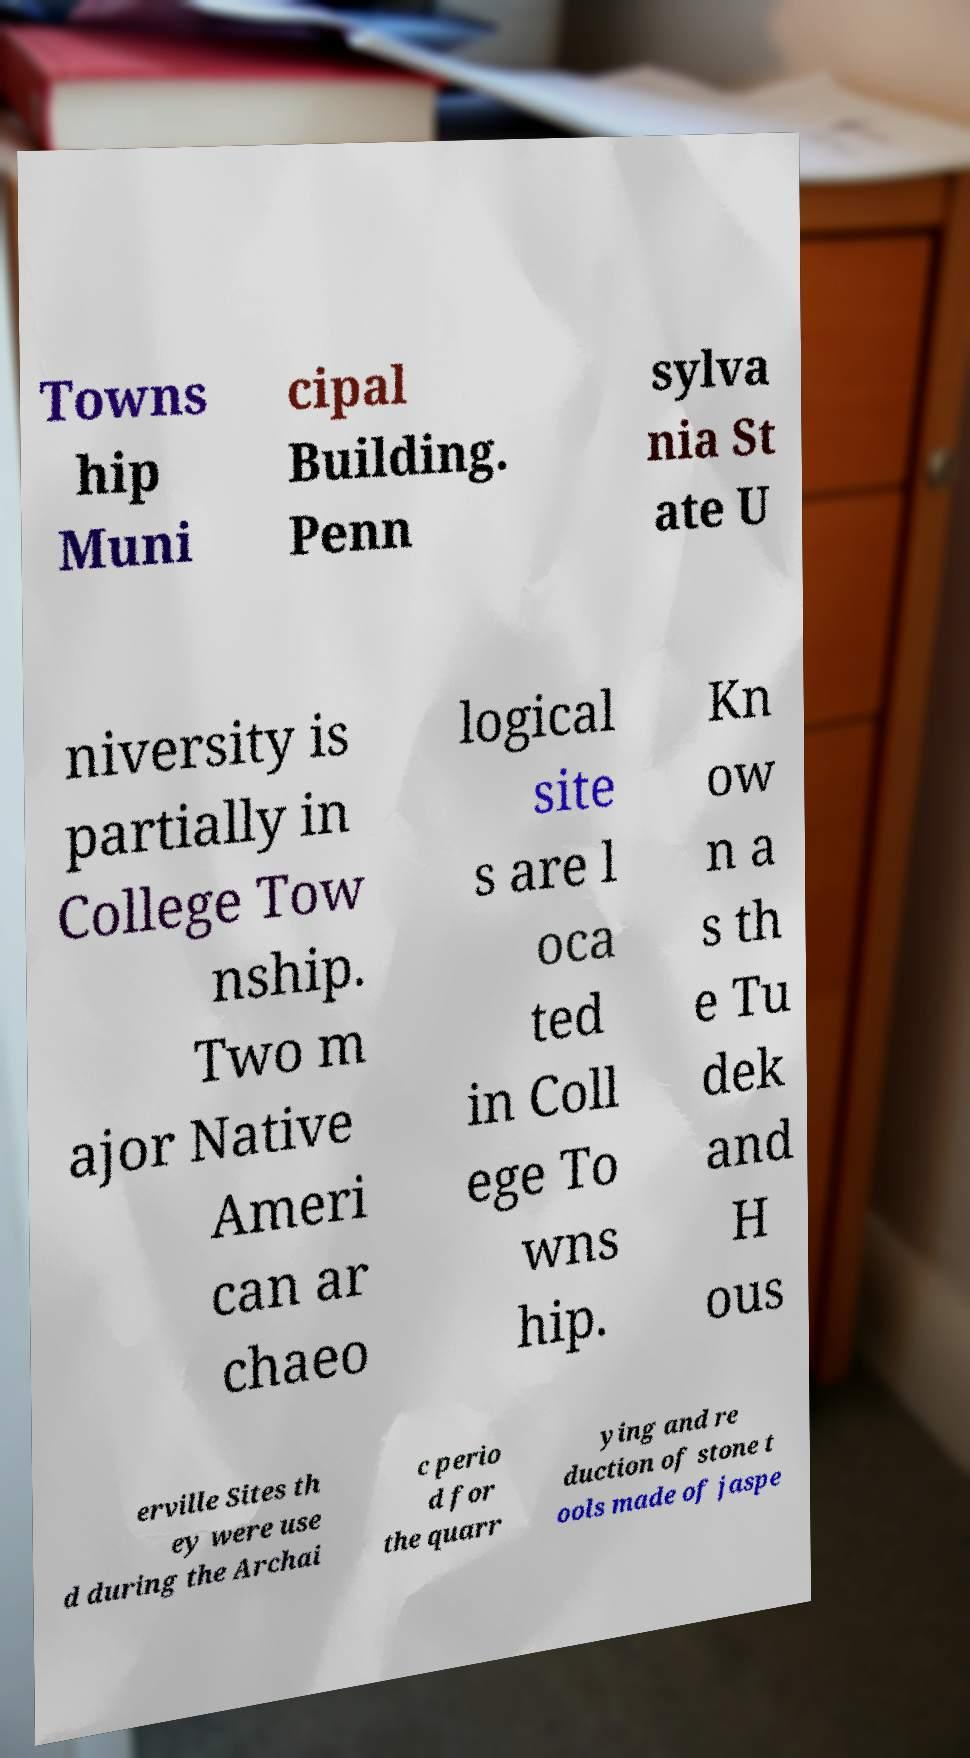For documentation purposes, I need the text within this image transcribed. Could you provide that? Towns hip Muni cipal Building. Penn sylva nia St ate U niversity is partially in College Tow nship. Two m ajor Native Ameri can ar chaeo logical site s are l oca ted in Coll ege To wns hip. Kn ow n a s th e Tu dek and H ous erville Sites th ey were use d during the Archai c perio d for the quarr ying and re duction of stone t ools made of jaspe 